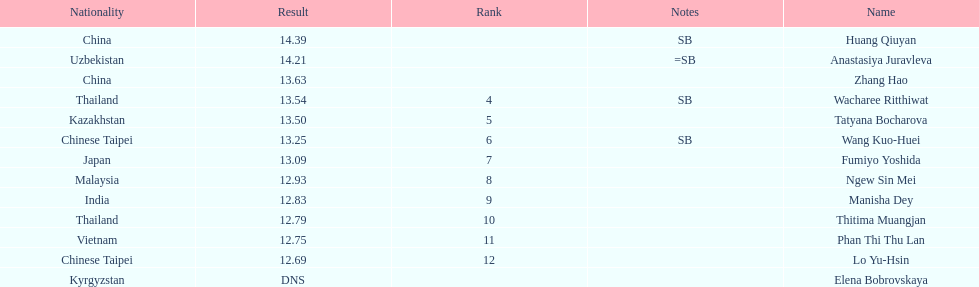What is the difference between huang qiuyan's result and fumiyo yoshida's result? 1.3. 